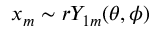<formula> <loc_0><loc_0><loc_500><loc_500>x _ { m } \sim r Y _ { 1 m } ( \theta , \phi )</formula> 